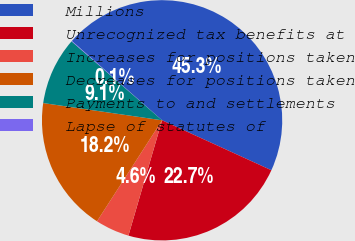Convert chart. <chart><loc_0><loc_0><loc_500><loc_500><pie_chart><fcel>Millions<fcel>Unrecognized tax benefits at<fcel>Increases for positions taken<fcel>Decreases for positions taken<fcel>Payments to and settlements<fcel>Lapse of statutes of<nl><fcel>45.34%<fcel>22.7%<fcel>4.59%<fcel>18.18%<fcel>9.12%<fcel>0.07%<nl></chart> 